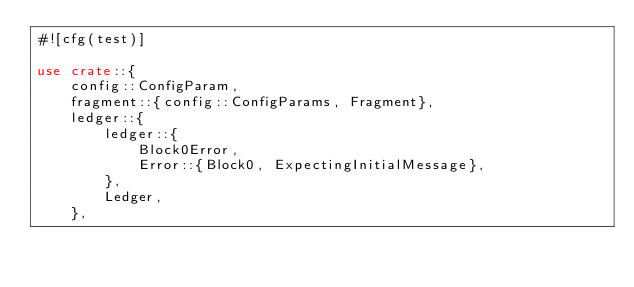<code> <loc_0><loc_0><loc_500><loc_500><_Rust_>#![cfg(test)]

use crate::{
    config::ConfigParam,
    fragment::{config::ConfigParams, Fragment},
    ledger::{
        ledger::{
            Block0Error,
            Error::{Block0, ExpectingInitialMessage},
        },
        Ledger,
    },</code> 